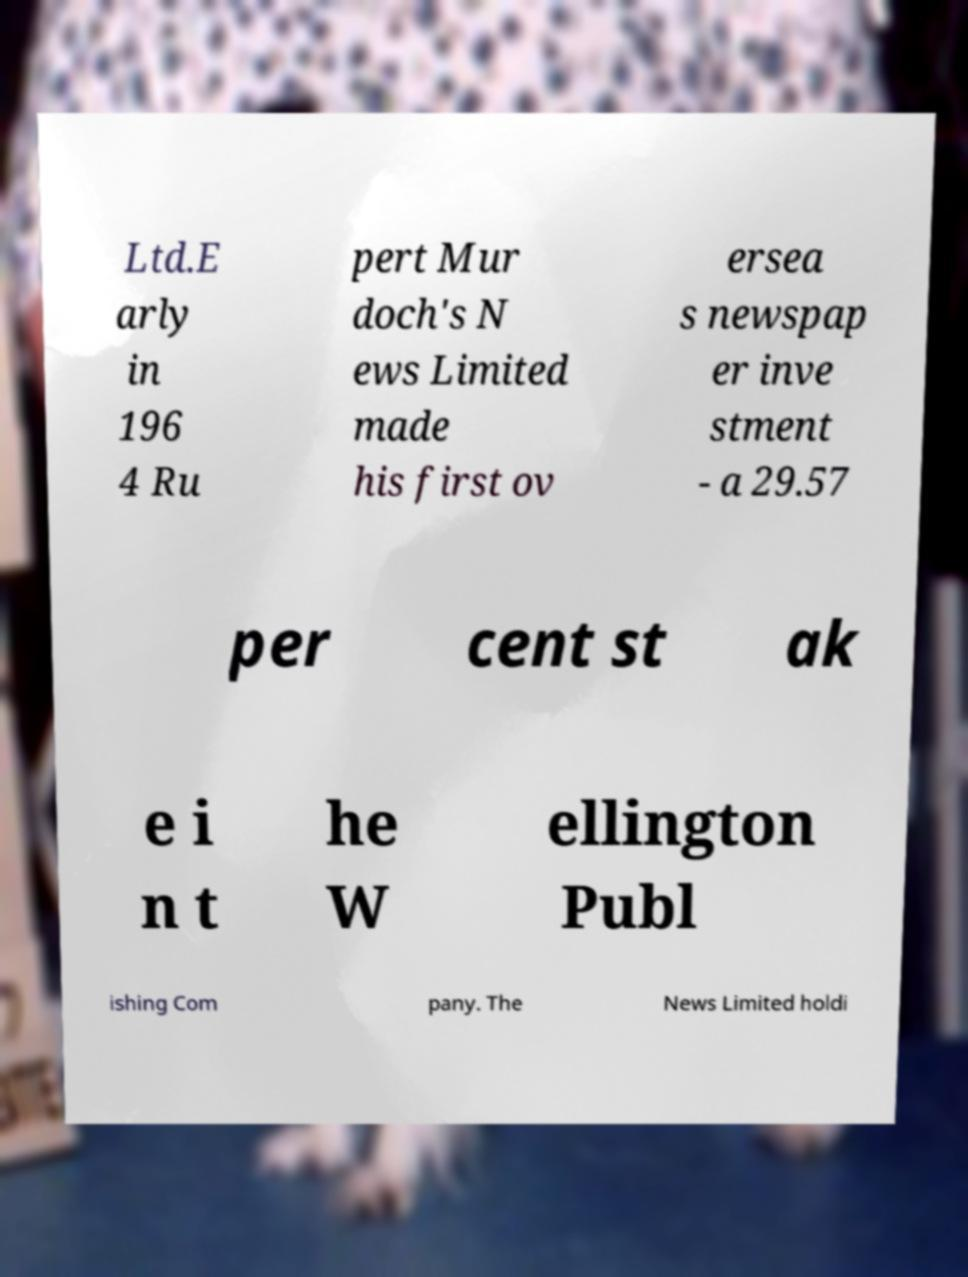There's text embedded in this image that I need extracted. Can you transcribe it verbatim? Ltd.E arly in 196 4 Ru pert Mur doch's N ews Limited made his first ov ersea s newspap er inve stment - a 29.57 per cent st ak e i n t he W ellington Publ ishing Com pany. The News Limited holdi 